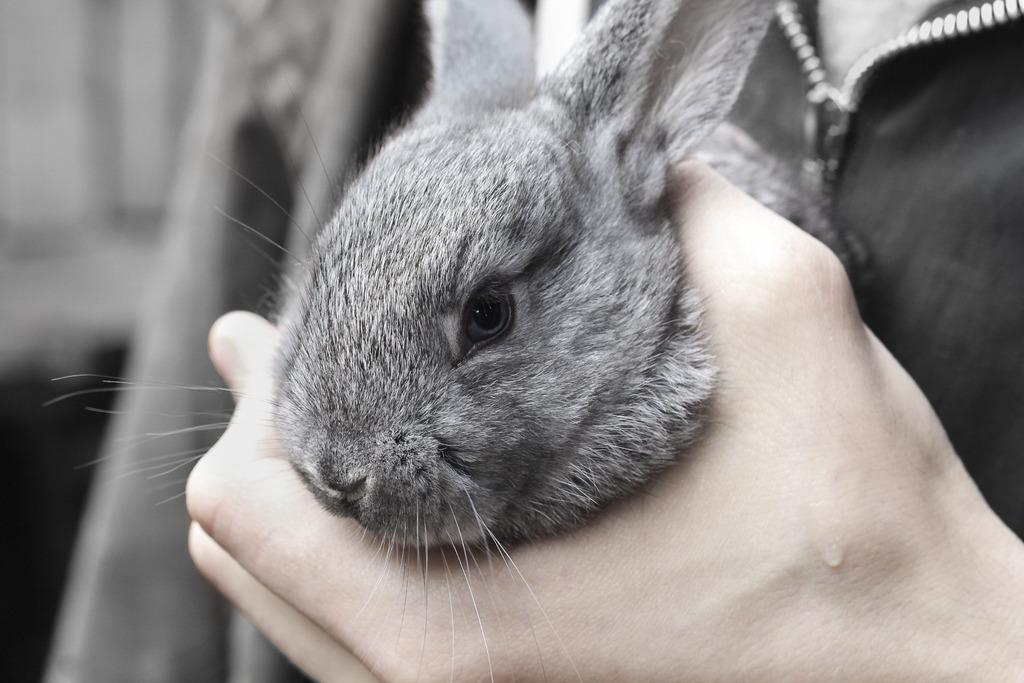What is being held in the hand in the image? A rabbit is held in the hand in the image. Can you describe the hand in the image? The hand belongs to a person, and it is holding the rabbit. What is the overall quality of the image? The image is slightly blurry in the background. What type of glue is being used to attach the plants to the hand in the image? There are no plants or glue present in the image; it features a hand holding a rabbit. 